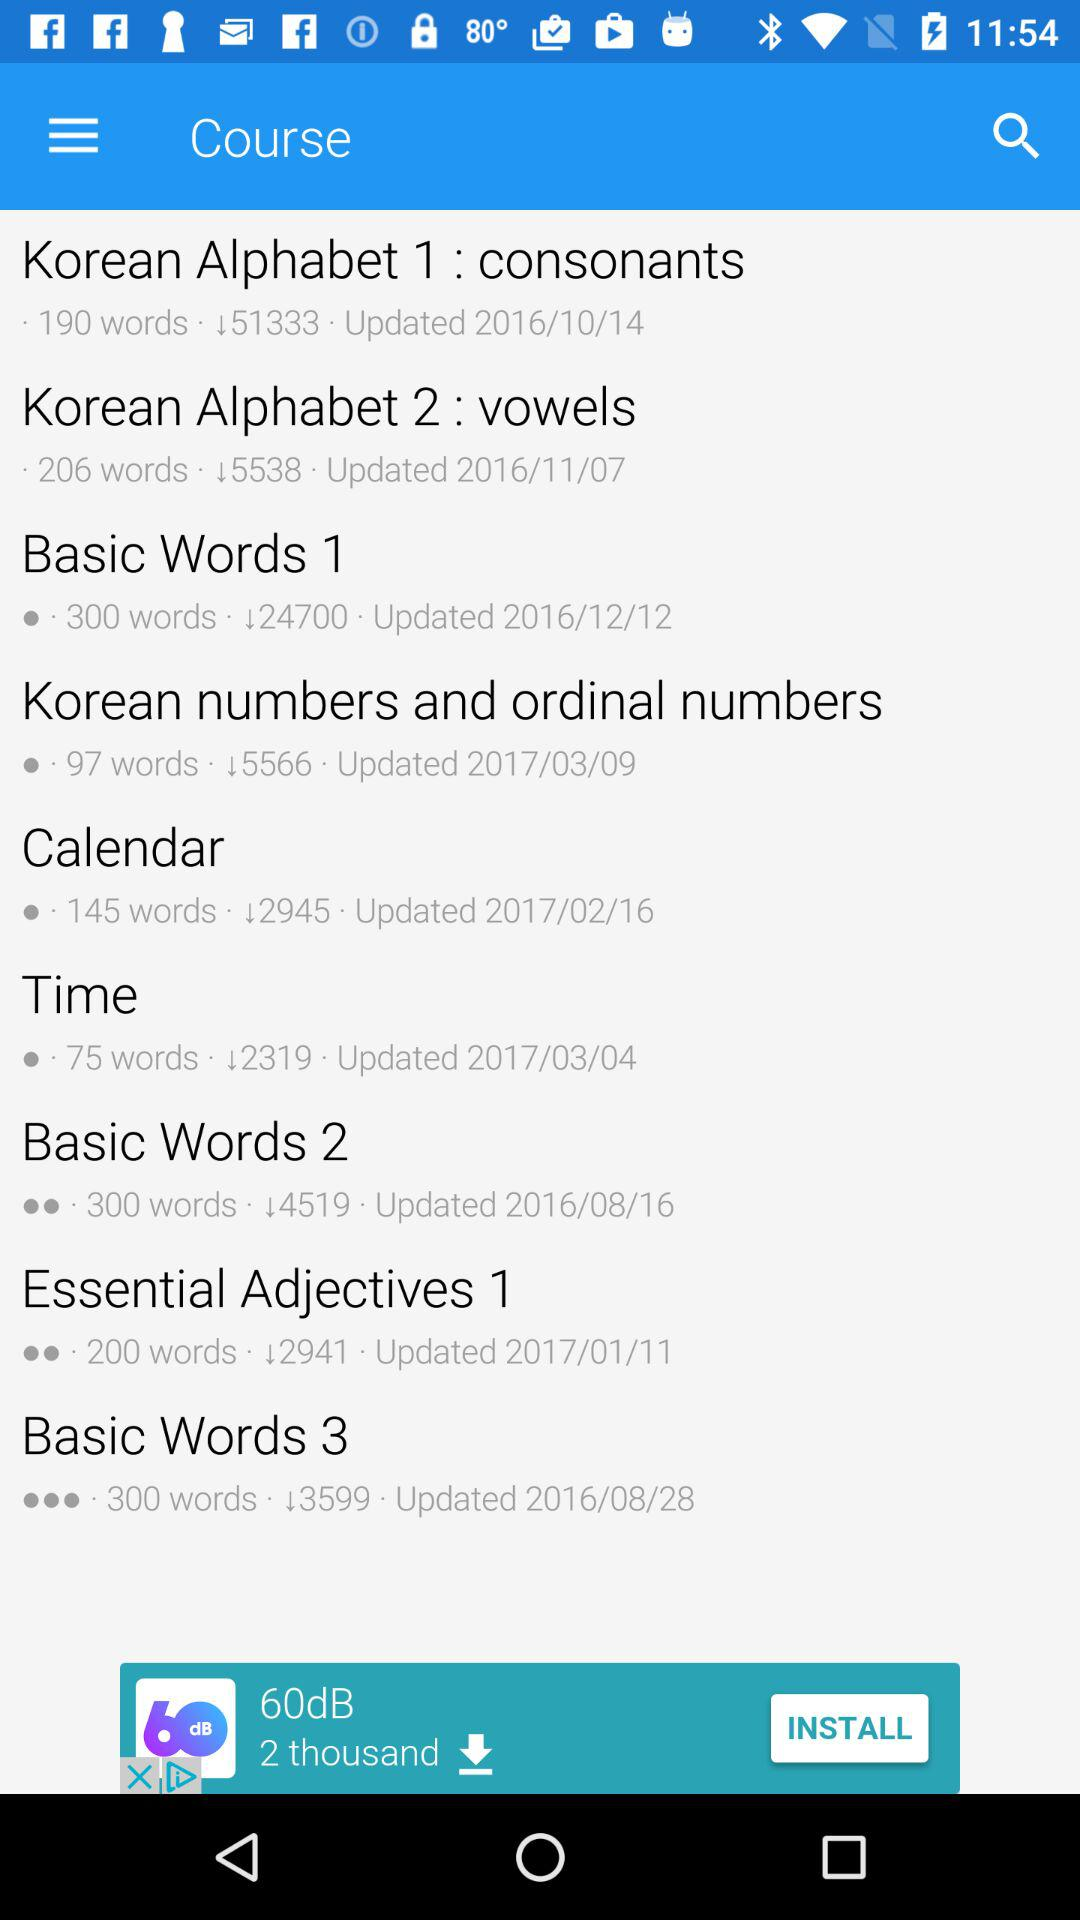When was the course "Basic Words 1" updated? The course "Basic Words 1" was updated on December 12, 2016. 